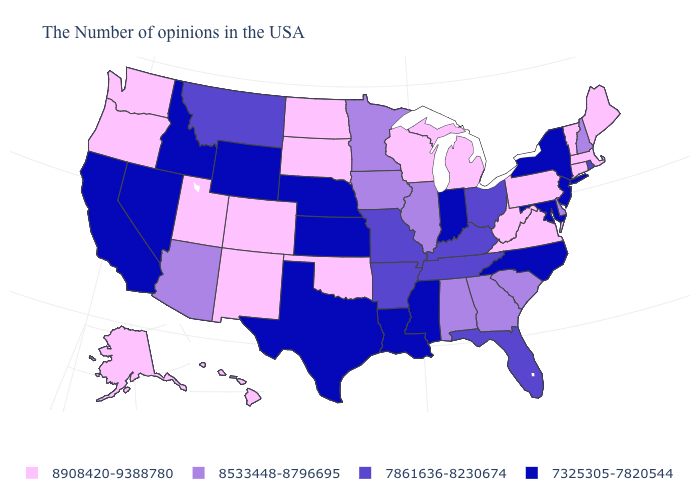Name the states that have a value in the range 7325305-7820544?
Be succinct. New York, New Jersey, Maryland, North Carolina, Indiana, Mississippi, Louisiana, Kansas, Nebraska, Texas, Wyoming, Idaho, Nevada, California. Name the states that have a value in the range 7861636-8230674?
Write a very short answer. Rhode Island, Ohio, Florida, Kentucky, Tennessee, Missouri, Arkansas, Montana. Does Wyoming have the lowest value in the West?
Keep it brief. Yes. What is the lowest value in the Northeast?
Concise answer only. 7325305-7820544. What is the lowest value in the USA?
Write a very short answer. 7325305-7820544. Among the states that border Alabama , which have the highest value?
Be succinct. Georgia. Which states hav the highest value in the South?
Concise answer only. Virginia, West Virginia, Oklahoma. What is the value of North Dakota?
Answer briefly. 8908420-9388780. What is the value of Mississippi?
Be succinct. 7325305-7820544. What is the value of Wisconsin?
Short answer required. 8908420-9388780. What is the highest value in the USA?
Answer briefly. 8908420-9388780. Does Wisconsin have the highest value in the MidWest?
Give a very brief answer. Yes. Does Montana have the highest value in the West?
Concise answer only. No. Does Alabama have a higher value than New Mexico?
Concise answer only. No. Among the states that border Arkansas , which have the highest value?
Give a very brief answer. Oklahoma. 